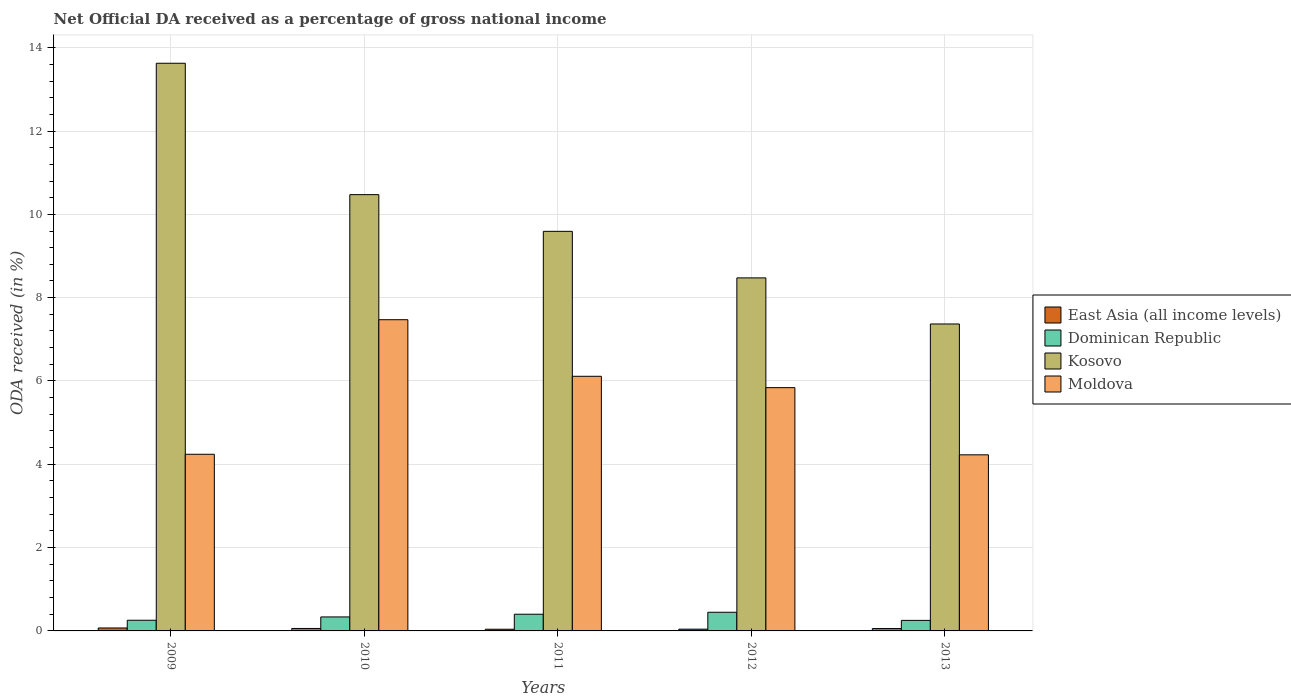How many different coloured bars are there?
Make the answer very short. 4. How many groups of bars are there?
Keep it short and to the point. 5. How many bars are there on the 1st tick from the left?
Ensure brevity in your answer.  4. How many bars are there on the 3rd tick from the right?
Keep it short and to the point. 4. What is the label of the 1st group of bars from the left?
Your response must be concise. 2009. What is the net official DA received in Moldova in 2010?
Keep it short and to the point. 7.47. Across all years, what is the maximum net official DA received in East Asia (all income levels)?
Your answer should be very brief. 0.07. Across all years, what is the minimum net official DA received in Kosovo?
Provide a succinct answer. 7.37. What is the total net official DA received in East Asia (all income levels) in the graph?
Offer a terse response. 0.27. What is the difference between the net official DA received in Moldova in 2009 and that in 2012?
Provide a short and direct response. -1.6. What is the difference between the net official DA received in Dominican Republic in 2010 and the net official DA received in Kosovo in 2013?
Keep it short and to the point. -7.03. What is the average net official DA received in Dominican Republic per year?
Your response must be concise. 0.34. In the year 2011, what is the difference between the net official DA received in Moldova and net official DA received in Kosovo?
Offer a very short reply. -3.48. What is the ratio of the net official DA received in Kosovo in 2011 to that in 2013?
Offer a terse response. 1.3. Is the net official DA received in Kosovo in 2009 less than that in 2012?
Ensure brevity in your answer.  No. What is the difference between the highest and the second highest net official DA received in Kosovo?
Ensure brevity in your answer.  3.15. What is the difference between the highest and the lowest net official DA received in Kosovo?
Your response must be concise. 6.26. What does the 3rd bar from the left in 2010 represents?
Make the answer very short. Kosovo. What does the 1st bar from the right in 2013 represents?
Provide a short and direct response. Moldova. Is it the case that in every year, the sum of the net official DA received in Dominican Republic and net official DA received in Kosovo is greater than the net official DA received in Moldova?
Provide a short and direct response. Yes. How many bars are there?
Provide a short and direct response. 20. Are all the bars in the graph horizontal?
Make the answer very short. No. How many years are there in the graph?
Ensure brevity in your answer.  5. Where does the legend appear in the graph?
Your answer should be compact. Center right. How many legend labels are there?
Keep it short and to the point. 4. What is the title of the graph?
Ensure brevity in your answer.  Net Official DA received as a percentage of gross national income. What is the label or title of the Y-axis?
Ensure brevity in your answer.  ODA received (in %). What is the ODA received (in %) in East Asia (all income levels) in 2009?
Offer a very short reply. 0.07. What is the ODA received (in %) of Dominican Republic in 2009?
Keep it short and to the point. 0.26. What is the ODA received (in %) of Kosovo in 2009?
Offer a very short reply. 13.63. What is the ODA received (in %) in Moldova in 2009?
Make the answer very short. 4.24. What is the ODA received (in %) of East Asia (all income levels) in 2010?
Your answer should be compact. 0.06. What is the ODA received (in %) in Dominican Republic in 2010?
Your answer should be compact. 0.34. What is the ODA received (in %) of Kosovo in 2010?
Give a very brief answer. 10.47. What is the ODA received (in %) in Moldova in 2010?
Your answer should be compact. 7.47. What is the ODA received (in %) of East Asia (all income levels) in 2011?
Ensure brevity in your answer.  0.04. What is the ODA received (in %) of Dominican Republic in 2011?
Offer a very short reply. 0.4. What is the ODA received (in %) of Kosovo in 2011?
Offer a very short reply. 9.59. What is the ODA received (in %) of Moldova in 2011?
Make the answer very short. 6.11. What is the ODA received (in %) in East Asia (all income levels) in 2012?
Provide a succinct answer. 0.04. What is the ODA received (in %) of Dominican Republic in 2012?
Provide a short and direct response. 0.45. What is the ODA received (in %) in Kosovo in 2012?
Make the answer very short. 8.47. What is the ODA received (in %) in Moldova in 2012?
Your answer should be very brief. 5.84. What is the ODA received (in %) in East Asia (all income levels) in 2013?
Keep it short and to the point. 0.06. What is the ODA received (in %) of Dominican Republic in 2013?
Provide a short and direct response. 0.25. What is the ODA received (in %) of Kosovo in 2013?
Your response must be concise. 7.37. What is the ODA received (in %) of Moldova in 2013?
Make the answer very short. 4.23. Across all years, what is the maximum ODA received (in %) in East Asia (all income levels)?
Your response must be concise. 0.07. Across all years, what is the maximum ODA received (in %) in Dominican Republic?
Your answer should be very brief. 0.45. Across all years, what is the maximum ODA received (in %) in Kosovo?
Make the answer very short. 13.63. Across all years, what is the maximum ODA received (in %) in Moldova?
Provide a succinct answer. 7.47. Across all years, what is the minimum ODA received (in %) in East Asia (all income levels)?
Your answer should be very brief. 0.04. Across all years, what is the minimum ODA received (in %) of Dominican Republic?
Give a very brief answer. 0.25. Across all years, what is the minimum ODA received (in %) of Kosovo?
Give a very brief answer. 7.37. Across all years, what is the minimum ODA received (in %) of Moldova?
Your answer should be very brief. 4.23. What is the total ODA received (in %) of East Asia (all income levels) in the graph?
Keep it short and to the point. 0.27. What is the total ODA received (in %) in Dominican Republic in the graph?
Provide a succinct answer. 1.69. What is the total ODA received (in %) of Kosovo in the graph?
Give a very brief answer. 49.53. What is the total ODA received (in %) in Moldova in the graph?
Ensure brevity in your answer.  27.89. What is the difference between the ODA received (in %) in East Asia (all income levels) in 2009 and that in 2010?
Ensure brevity in your answer.  0.01. What is the difference between the ODA received (in %) in Dominican Republic in 2009 and that in 2010?
Your answer should be very brief. -0.08. What is the difference between the ODA received (in %) in Kosovo in 2009 and that in 2010?
Your answer should be compact. 3.15. What is the difference between the ODA received (in %) of Moldova in 2009 and that in 2010?
Offer a terse response. -3.23. What is the difference between the ODA received (in %) of East Asia (all income levels) in 2009 and that in 2011?
Give a very brief answer. 0.03. What is the difference between the ODA received (in %) of Dominican Republic in 2009 and that in 2011?
Your answer should be very brief. -0.14. What is the difference between the ODA received (in %) in Kosovo in 2009 and that in 2011?
Keep it short and to the point. 4.03. What is the difference between the ODA received (in %) of Moldova in 2009 and that in 2011?
Keep it short and to the point. -1.87. What is the difference between the ODA received (in %) of East Asia (all income levels) in 2009 and that in 2012?
Your response must be concise. 0.03. What is the difference between the ODA received (in %) in Dominican Republic in 2009 and that in 2012?
Give a very brief answer. -0.19. What is the difference between the ODA received (in %) in Kosovo in 2009 and that in 2012?
Offer a terse response. 5.15. What is the difference between the ODA received (in %) in Moldova in 2009 and that in 2012?
Your answer should be compact. -1.6. What is the difference between the ODA received (in %) in East Asia (all income levels) in 2009 and that in 2013?
Offer a terse response. 0.01. What is the difference between the ODA received (in %) of Dominican Republic in 2009 and that in 2013?
Your response must be concise. 0. What is the difference between the ODA received (in %) of Kosovo in 2009 and that in 2013?
Make the answer very short. 6.26. What is the difference between the ODA received (in %) of Moldova in 2009 and that in 2013?
Offer a terse response. 0.01. What is the difference between the ODA received (in %) of East Asia (all income levels) in 2010 and that in 2011?
Your response must be concise. 0.02. What is the difference between the ODA received (in %) of Dominican Republic in 2010 and that in 2011?
Offer a very short reply. -0.06. What is the difference between the ODA received (in %) of Kosovo in 2010 and that in 2011?
Offer a terse response. 0.88. What is the difference between the ODA received (in %) in Moldova in 2010 and that in 2011?
Offer a terse response. 1.36. What is the difference between the ODA received (in %) of East Asia (all income levels) in 2010 and that in 2012?
Ensure brevity in your answer.  0.02. What is the difference between the ODA received (in %) in Dominican Republic in 2010 and that in 2012?
Offer a terse response. -0.11. What is the difference between the ODA received (in %) of Kosovo in 2010 and that in 2012?
Make the answer very short. 2. What is the difference between the ODA received (in %) in Moldova in 2010 and that in 2012?
Make the answer very short. 1.63. What is the difference between the ODA received (in %) of East Asia (all income levels) in 2010 and that in 2013?
Ensure brevity in your answer.  0. What is the difference between the ODA received (in %) in Dominican Republic in 2010 and that in 2013?
Make the answer very short. 0.08. What is the difference between the ODA received (in %) of Kosovo in 2010 and that in 2013?
Offer a terse response. 3.1. What is the difference between the ODA received (in %) of Moldova in 2010 and that in 2013?
Your answer should be compact. 3.24. What is the difference between the ODA received (in %) of East Asia (all income levels) in 2011 and that in 2012?
Make the answer very short. -0. What is the difference between the ODA received (in %) in Dominican Republic in 2011 and that in 2012?
Provide a short and direct response. -0.05. What is the difference between the ODA received (in %) in Kosovo in 2011 and that in 2012?
Offer a terse response. 1.12. What is the difference between the ODA received (in %) of Moldova in 2011 and that in 2012?
Give a very brief answer. 0.27. What is the difference between the ODA received (in %) in East Asia (all income levels) in 2011 and that in 2013?
Provide a short and direct response. -0.02. What is the difference between the ODA received (in %) of Dominican Republic in 2011 and that in 2013?
Offer a terse response. 0.15. What is the difference between the ODA received (in %) in Kosovo in 2011 and that in 2013?
Your response must be concise. 2.22. What is the difference between the ODA received (in %) in Moldova in 2011 and that in 2013?
Provide a succinct answer. 1.88. What is the difference between the ODA received (in %) of East Asia (all income levels) in 2012 and that in 2013?
Provide a succinct answer. -0.01. What is the difference between the ODA received (in %) in Dominican Republic in 2012 and that in 2013?
Make the answer very short. 0.19. What is the difference between the ODA received (in %) in Kosovo in 2012 and that in 2013?
Provide a short and direct response. 1.11. What is the difference between the ODA received (in %) in Moldova in 2012 and that in 2013?
Your answer should be compact. 1.61. What is the difference between the ODA received (in %) in East Asia (all income levels) in 2009 and the ODA received (in %) in Dominican Republic in 2010?
Your answer should be compact. -0.27. What is the difference between the ODA received (in %) in East Asia (all income levels) in 2009 and the ODA received (in %) in Kosovo in 2010?
Ensure brevity in your answer.  -10.4. What is the difference between the ODA received (in %) in East Asia (all income levels) in 2009 and the ODA received (in %) in Moldova in 2010?
Your answer should be very brief. -7.4. What is the difference between the ODA received (in %) in Dominican Republic in 2009 and the ODA received (in %) in Kosovo in 2010?
Offer a terse response. -10.22. What is the difference between the ODA received (in %) in Dominican Republic in 2009 and the ODA received (in %) in Moldova in 2010?
Your response must be concise. -7.21. What is the difference between the ODA received (in %) of Kosovo in 2009 and the ODA received (in %) of Moldova in 2010?
Offer a very short reply. 6.16. What is the difference between the ODA received (in %) of East Asia (all income levels) in 2009 and the ODA received (in %) of Dominican Republic in 2011?
Provide a succinct answer. -0.33. What is the difference between the ODA received (in %) in East Asia (all income levels) in 2009 and the ODA received (in %) in Kosovo in 2011?
Offer a very short reply. -9.52. What is the difference between the ODA received (in %) in East Asia (all income levels) in 2009 and the ODA received (in %) in Moldova in 2011?
Your response must be concise. -6.04. What is the difference between the ODA received (in %) in Dominican Republic in 2009 and the ODA received (in %) in Kosovo in 2011?
Your response must be concise. -9.34. What is the difference between the ODA received (in %) of Dominican Republic in 2009 and the ODA received (in %) of Moldova in 2011?
Offer a very short reply. -5.86. What is the difference between the ODA received (in %) in Kosovo in 2009 and the ODA received (in %) in Moldova in 2011?
Your answer should be compact. 7.51. What is the difference between the ODA received (in %) in East Asia (all income levels) in 2009 and the ODA received (in %) in Dominican Republic in 2012?
Your answer should be compact. -0.38. What is the difference between the ODA received (in %) in East Asia (all income levels) in 2009 and the ODA received (in %) in Kosovo in 2012?
Give a very brief answer. -8.4. What is the difference between the ODA received (in %) in East Asia (all income levels) in 2009 and the ODA received (in %) in Moldova in 2012?
Your answer should be compact. -5.77. What is the difference between the ODA received (in %) of Dominican Republic in 2009 and the ODA received (in %) of Kosovo in 2012?
Provide a short and direct response. -8.22. What is the difference between the ODA received (in %) in Dominican Republic in 2009 and the ODA received (in %) in Moldova in 2012?
Ensure brevity in your answer.  -5.58. What is the difference between the ODA received (in %) in Kosovo in 2009 and the ODA received (in %) in Moldova in 2012?
Ensure brevity in your answer.  7.79. What is the difference between the ODA received (in %) of East Asia (all income levels) in 2009 and the ODA received (in %) of Dominican Republic in 2013?
Ensure brevity in your answer.  -0.18. What is the difference between the ODA received (in %) in East Asia (all income levels) in 2009 and the ODA received (in %) in Kosovo in 2013?
Your answer should be compact. -7.3. What is the difference between the ODA received (in %) in East Asia (all income levels) in 2009 and the ODA received (in %) in Moldova in 2013?
Keep it short and to the point. -4.16. What is the difference between the ODA received (in %) of Dominican Republic in 2009 and the ODA received (in %) of Kosovo in 2013?
Provide a short and direct response. -7.11. What is the difference between the ODA received (in %) of Dominican Republic in 2009 and the ODA received (in %) of Moldova in 2013?
Provide a succinct answer. -3.97. What is the difference between the ODA received (in %) in Kosovo in 2009 and the ODA received (in %) in Moldova in 2013?
Provide a succinct answer. 9.4. What is the difference between the ODA received (in %) in East Asia (all income levels) in 2010 and the ODA received (in %) in Dominican Republic in 2011?
Ensure brevity in your answer.  -0.34. What is the difference between the ODA received (in %) in East Asia (all income levels) in 2010 and the ODA received (in %) in Kosovo in 2011?
Provide a short and direct response. -9.53. What is the difference between the ODA received (in %) of East Asia (all income levels) in 2010 and the ODA received (in %) of Moldova in 2011?
Offer a very short reply. -6.05. What is the difference between the ODA received (in %) in Dominican Republic in 2010 and the ODA received (in %) in Kosovo in 2011?
Offer a very short reply. -9.26. What is the difference between the ODA received (in %) of Dominican Republic in 2010 and the ODA received (in %) of Moldova in 2011?
Make the answer very short. -5.78. What is the difference between the ODA received (in %) in Kosovo in 2010 and the ODA received (in %) in Moldova in 2011?
Your answer should be very brief. 4.36. What is the difference between the ODA received (in %) of East Asia (all income levels) in 2010 and the ODA received (in %) of Dominican Republic in 2012?
Provide a short and direct response. -0.39. What is the difference between the ODA received (in %) of East Asia (all income levels) in 2010 and the ODA received (in %) of Kosovo in 2012?
Provide a short and direct response. -8.42. What is the difference between the ODA received (in %) of East Asia (all income levels) in 2010 and the ODA received (in %) of Moldova in 2012?
Provide a succinct answer. -5.78. What is the difference between the ODA received (in %) of Dominican Republic in 2010 and the ODA received (in %) of Kosovo in 2012?
Make the answer very short. -8.14. What is the difference between the ODA received (in %) in Dominican Republic in 2010 and the ODA received (in %) in Moldova in 2012?
Your response must be concise. -5.5. What is the difference between the ODA received (in %) in Kosovo in 2010 and the ODA received (in %) in Moldova in 2012?
Make the answer very short. 4.63. What is the difference between the ODA received (in %) in East Asia (all income levels) in 2010 and the ODA received (in %) in Dominican Republic in 2013?
Ensure brevity in your answer.  -0.19. What is the difference between the ODA received (in %) of East Asia (all income levels) in 2010 and the ODA received (in %) of Kosovo in 2013?
Offer a very short reply. -7.31. What is the difference between the ODA received (in %) in East Asia (all income levels) in 2010 and the ODA received (in %) in Moldova in 2013?
Offer a terse response. -4.17. What is the difference between the ODA received (in %) of Dominican Republic in 2010 and the ODA received (in %) of Kosovo in 2013?
Ensure brevity in your answer.  -7.03. What is the difference between the ODA received (in %) in Dominican Republic in 2010 and the ODA received (in %) in Moldova in 2013?
Make the answer very short. -3.89. What is the difference between the ODA received (in %) of Kosovo in 2010 and the ODA received (in %) of Moldova in 2013?
Your answer should be very brief. 6.25. What is the difference between the ODA received (in %) in East Asia (all income levels) in 2011 and the ODA received (in %) in Dominican Republic in 2012?
Ensure brevity in your answer.  -0.41. What is the difference between the ODA received (in %) of East Asia (all income levels) in 2011 and the ODA received (in %) of Kosovo in 2012?
Your answer should be very brief. -8.43. What is the difference between the ODA received (in %) in East Asia (all income levels) in 2011 and the ODA received (in %) in Moldova in 2012?
Your answer should be very brief. -5.8. What is the difference between the ODA received (in %) of Dominican Republic in 2011 and the ODA received (in %) of Kosovo in 2012?
Your answer should be compact. -8.07. What is the difference between the ODA received (in %) of Dominican Republic in 2011 and the ODA received (in %) of Moldova in 2012?
Your answer should be compact. -5.44. What is the difference between the ODA received (in %) in Kosovo in 2011 and the ODA received (in %) in Moldova in 2012?
Ensure brevity in your answer.  3.75. What is the difference between the ODA received (in %) in East Asia (all income levels) in 2011 and the ODA received (in %) in Dominican Republic in 2013?
Give a very brief answer. -0.21. What is the difference between the ODA received (in %) of East Asia (all income levels) in 2011 and the ODA received (in %) of Kosovo in 2013?
Ensure brevity in your answer.  -7.33. What is the difference between the ODA received (in %) of East Asia (all income levels) in 2011 and the ODA received (in %) of Moldova in 2013?
Offer a terse response. -4.19. What is the difference between the ODA received (in %) of Dominican Republic in 2011 and the ODA received (in %) of Kosovo in 2013?
Make the answer very short. -6.97. What is the difference between the ODA received (in %) in Dominican Republic in 2011 and the ODA received (in %) in Moldova in 2013?
Your answer should be very brief. -3.83. What is the difference between the ODA received (in %) of Kosovo in 2011 and the ODA received (in %) of Moldova in 2013?
Offer a very short reply. 5.36. What is the difference between the ODA received (in %) in East Asia (all income levels) in 2012 and the ODA received (in %) in Dominican Republic in 2013?
Your answer should be very brief. -0.21. What is the difference between the ODA received (in %) of East Asia (all income levels) in 2012 and the ODA received (in %) of Kosovo in 2013?
Provide a succinct answer. -7.33. What is the difference between the ODA received (in %) in East Asia (all income levels) in 2012 and the ODA received (in %) in Moldova in 2013?
Provide a short and direct response. -4.18. What is the difference between the ODA received (in %) in Dominican Republic in 2012 and the ODA received (in %) in Kosovo in 2013?
Provide a succinct answer. -6.92. What is the difference between the ODA received (in %) in Dominican Republic in 2012 and the ODA received (in %) in Moldova in 2013?
Your answer should be very brief. -3.78. What is the difference between the ODA received (in %) in Kosovo in 2012 and the ODA received (in %) in Moldova in 2013?
Make the answer very short. 4.25. What is the average ODA received (in %) in East Asia (all income levels) per year?
Make the answer very short. 0.05. What is the average ODA received (in %) of Dominican Republic per year?
Your response must be concise. 0.34. What is the average ODA received (in %) of Kosovo per year?
Your answer should be very brief. 9.91. What is the average ODA received (in %) in Moldova per year?
Make the answer very short. 5.58. In the year 2009, what is the difference between the ODA received (in %) in East Asia (all income levels) and ODA received (in %) in Dominican Republic?
Offer a very short reply. -0.19. In the year 2009, what is the difference between the ODA received (in %) of East Asia (all income levels) and ODA received (in %) of Kosovo?
Ensure brevity in your answer.  -13.56. In the year 2009, what is the difference between the ODA received (in %) of East Asia (all income levels) and ODA received (in %) of Moldova?
Make the answer very short. -4.17. In the year 2009, what is the difference between the ODA received (in %) of Dominican Republic and ODA received (in %) of Kosovo?
Ensure brevity in your answer.  -13.37. In the year 2009, what is the difference between the ODA received (in %) in Dominican Republic and ODA received (in %) in Moldova?
Your response must be concise. -3.98. In the year 2009, what is the difference between the ODA received (in %) of Kosovo and ODA received (in %) of Moldova?
Your response must be concise. 9.39. In the year 2010, what is the difference between the ODA received (in %) of East Asia (all income levels) and ODA received (in %) of Dominican Republic?
Provide a short and direct response. -0.28. In the year 2010, what is the difference between the ODA received (in %) in East Asia (all income levels) and ODA received (in %) in Kosovo?
Offer a terse response. -10.41. In the year 2010, what is the difference between the ODA received (in %) in East Asia (all income levels) and ODA received (in %) in Moldova?
Offer a terse response. -7.41. In the year 2010, what is the difference between the ODA received (in %) of Dominican Republic and ODA received (in %) of Kosovo?
Your answer should be compact. -10.14. In the year 2010, what is the difference between the ODA received (in %) of Dominican Republic and ODA received (in %) of Moldova?
Make the answer very short. -7.13. In the year 2010, what is the difference between the ODA received (in %) of Kosovo and ODA received (in %) of Moldova?
Keep it short and to the point. 3. In the year 2011, what is the difference between the ODA received (in %) of East Asia (all income levels) and ODA received (in %) of Dominican Republic?
Offer a very short reply. -0.36. In the year 2011, what is the difference between the ODA received (in %) in East Asia (all income levels) and ODA received (in %) in Kosovo?
Your answer should be very brief. -9.55. In the year 2011, what is the difference between the ODA received (in %) in East Asia (all income levels) and ODA received (in %) in Moldova?
Provide a short and direct response. -6.07. In the year 2011, what is the difference between the ODA received (in %) of Dominican Republic and ODA received (in %) of Kosovo?
Give a very brief answer. -9.19. In the year 2011, what is the difference between the ODA received (in %) in Dominican Republic and ODA received (in %) in Moldova?
Provide a short and direct response. -5.71. In the year 2011, what is the difference between the ODA received (in %) in Kosovo and ODA received (in %) in Moldova?
Your answer should be compact. 3.48. In the year 2012, what is the difference between the ODA received (in %) in East Asia (all income levels) and ODA received (in %) in Dominican Republic?
Keep it short and to the point. -0.41. In the year 2012, what is the difference between the ODA received (in %) of East Asia (all income levels) and ODA received (in %) of Kosovo?
Offer a terse response. -8.43. In the year 2012, what is the difference between the ODA received (in %) of East Asia (all income levels) and ODA received (in %) of Moldova?
Your response must be concise. -5.8. In the year 2012, what is the difference between the ODA received (in %) in Dominican Republic and ODA received (in %) in Kosovo?
Give a very brief answer. -8.03. In the year 2012, what is the difference between the ODA received (in %) of Dominican Republic and ODA received (in %) of Moldova?
Give a very brief answer. -5.39. In the year 2012, what is the difference between the ODA received (in %) of Kosovo and ODA received (in %) of Moldova?
Make the answer very short. 2.63. In the year 2013, what is the difference between the ODA received (in %) in East Asia (all income levels) and ODA received (in %) in Dominican Republic?
Keep it short and to the point. -0.2. In the year 2013, what is the difference between the ODA received (in %) in East Asia (all income levels) and ODA received (in %) in Kosovo?
Offer a very short reply. -7.31. In the year 2013, what is the difference between the ODA received (in %) of East Asia (all income levels) and ODA received (in %) of Moldova?
Keep it short and to the point. -4.17. In the year 2013, what is the difference between the ODA received (in %) of Dominican Republic and ODA received (in %) of Kosovo?
Give a very brief answer. -7.12. In the year 2013, what is the difference between the ODA received (in %) in Dominican Republic and ODA received (in %) in Moldova?
Offer a very short reply. -3.97. In the year 2013, what is the difference between the ODA received (in %) in Kosovo and ODA received (in %) in Moldova?
Provide a succinct answer. 3.14. What is the ratio of the ODA received (in %) in East Asia (all income levels) in 2009 to that in 2010?
Your answer should be compact. 1.2. What is the ratio of the ODA received (in %) in Dominican Republic in 2009 to that in 2010?
Keep it short and to the point. 0.76. What is the ratio of the ODA received (in %) of Kosovo in 2009 to that in 2010?
Keep it short and to the point. 1.3. What is the ratio of the ODA received (in %) of Moldova in 2009 to that in 2010?
Ensure brevity in your answer.  0.57. What is the ratio of the ODA received (in %) of East Asia (all income levels) in 2009 to that in 2011?
Provide a succinct answer. 1.76. What is the ratio of the ODA received (in %) in Dominican Republic in 2009 to that in 2011?
Offer a very short reply. 0.64. What is the ratio of the ODA received (in %) of Kosovo in 2009 to that in 2011?
Offer a very short reply. 1.42. What is the ratio of the ODA received (in %) in Moldova in 2009 to that in 2011?
Give a very brief answer. 0.69. What is the ratio of the ODA received (in %) in East Asia (all income levels) in 2009 to that in 2012?
Your answer should be very brief. 1.67. What is the ratio of the ODA received (in %) of Dominican Republic in 2009 to that in 2012?
Your response must be concise. 0.57. What is the ratio of the ODA received (in %) in Kosovo in 2009 to that in 2012?
Provide a succinct answer. 1.61. What is the ratio of the ODA received (in %) in Moldova in 2009 to that in 2012?
Offer a very short reply. 0.73. What is the ratio of the ODA received (in %) of East Asia (all income levels) in 2009 to that in 2013?
Offer a terse response. 1.24. What is the ratio of the ODA received (in %) in Kosovo in 2009 to that in 2013?
Your response must be concise. 1.85. What is the ratio of the ODA received (in %) in East Asia (all income levels) in 2010 to that in 2011?
Ensure brevity in your answer.  1.46. What is the ratio of the ODA received (in %) of Dominican Republic in 2010 to that in 2011?
Offer a terse response. 0.84. What is the ratio of the ODA received (in %) of Kosovo in 2010 to that in 2011?
Provide a succinct answer. 1.09. What is the ratio of the ODA received (in %) of Moldova in 2010 to that in 2011?
Give a very brief answer. 1.22. What is the ratio of the ODA received (in %) of East Asia (all income levels) in 2010 to that in 2012?
Your answer should be compact. 1.39. What is the ratio of the ODA received (in %) of Dominican Republic in 2010 to that in 2012?
Provide a short and direct response. 0.75. What is the ratio of the ODA received (in %) in Kosovo in 2010 to that in 2012?
Offer a terse response. 1.24. What is the ratio of the ODA received (in %) of Moldova in 2010 to that in 2012?
Offer a terse response. 1.28. What is the ratio of the ODA received (in %) in East Asia (all income levels) in 2010 to that in 2013?
Give a very brief answer. 1.04. What is the ratio of the ODA received (in %) of Dominican Republic in 2010 to that in 2013?
Keep it short and to the point. 1.33. What is the ratio of the ODA received (in %) in Kosovo in 2010 to that in 2013?
Offer a very short reply. 1.42. What is the ratio of the ODA received (in %) in Moldova in 2010 to that in 2013?
Make the answer very short. 1.77. What is the ratio of the ODA received (in %) of East Asia (all income levels) in 2011 to that in 2012?
Offer a very short reply. 0.95. What is the ratio of the ODA received (in %) in Dominican Republic in 2011 to that in 2012?
Ensure brevity in your answer.  0.89. What is the ratio of the ODA received (in %) in Kosovo in 2011 to that in 2012?
Provide a short and direct response. 1.13. What is the ratio of the ODA received (in %) of Moldova in 2011 to that in 2012?
Your response must be concise. 1.05. What is the ratio of the ODA received (in %) of East Asia (all income levels) in 2011 to that in 2013?
Offer a very short reply. 0.71. What is the ratio of the ODA received (in %) in Dominican Republic in 2011 to that in 2013?
Offer a terse response. 1.58. What is the ratio of the ODA received (in %) of Kosovo in 2011 to that in 2013?
Your response must be concise. 1.3. What is the ratio of the ODA received (in %) in Moldova in 2011 to that in 2013?
Give a very brief answer. 1.45. What is the ratio of the ODA received (in %) in East Asia (all income levels) in 2012 to that in 2013?
Your answer should be compact. 0.75. What is the ratio of the ODA received (in %) of Dominican Republic in 2012 to that in 2013?
Offer a very short reply. 1.77. What is the ratio of the ODA received (in %) of Kosovo in 2012 to that in 2013?
Offer a very short reply. 1.15. What is the ratio of the ODA received (in %) of Moldova in 2012 to that in 2013?
Offer a very short reply. 1.38. What is the difference between the highest and the second highest ODA received (in %) in East Asia (all income levels)?
Your answer should be very brief. 0.01. What is the difference between the highest and the second highest ODA received (in %) of Dominican Republic?
Ensure brevity in your answer.  0.05. What is the difference between the highest and the second highest ODA received (in %) in Kosovo?
Your answer should be very brief. 3.15. What is the difference between the highest and the second highest ODA received (in %) of Moldova?
Your answer should be very brief. 1.36. What is the difference between the highest and the lowest ODA received (in %) of East Asia (all income levels)?
Provide a short and direct response. 0.03. What is the difference between the highest and the lowest ODA received (in %) in Dominican Republic?
Give a very brief answer. 0.19. What is the difference between the highest and the lowest ODA received (in %) in Kosovo?
Offer a very short reply. 6.26. What is the difference between the highest and the lowest ODA received (in %) in Moldova?
Keep it short and to the point. 3.24. 